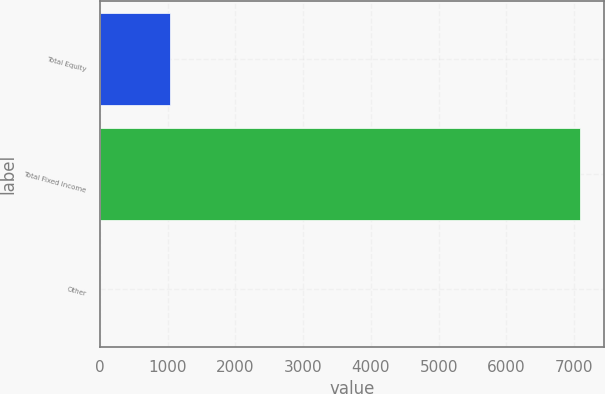Convert chart. <chart><loc_0><loc_0><loc_500><loc_500><bar_chart><fcel>Total Equity<fcel>Total Fixed Income<fcel>Other<nl><fcel>1030<fcel>7090<fcel>10<nl></chart> 